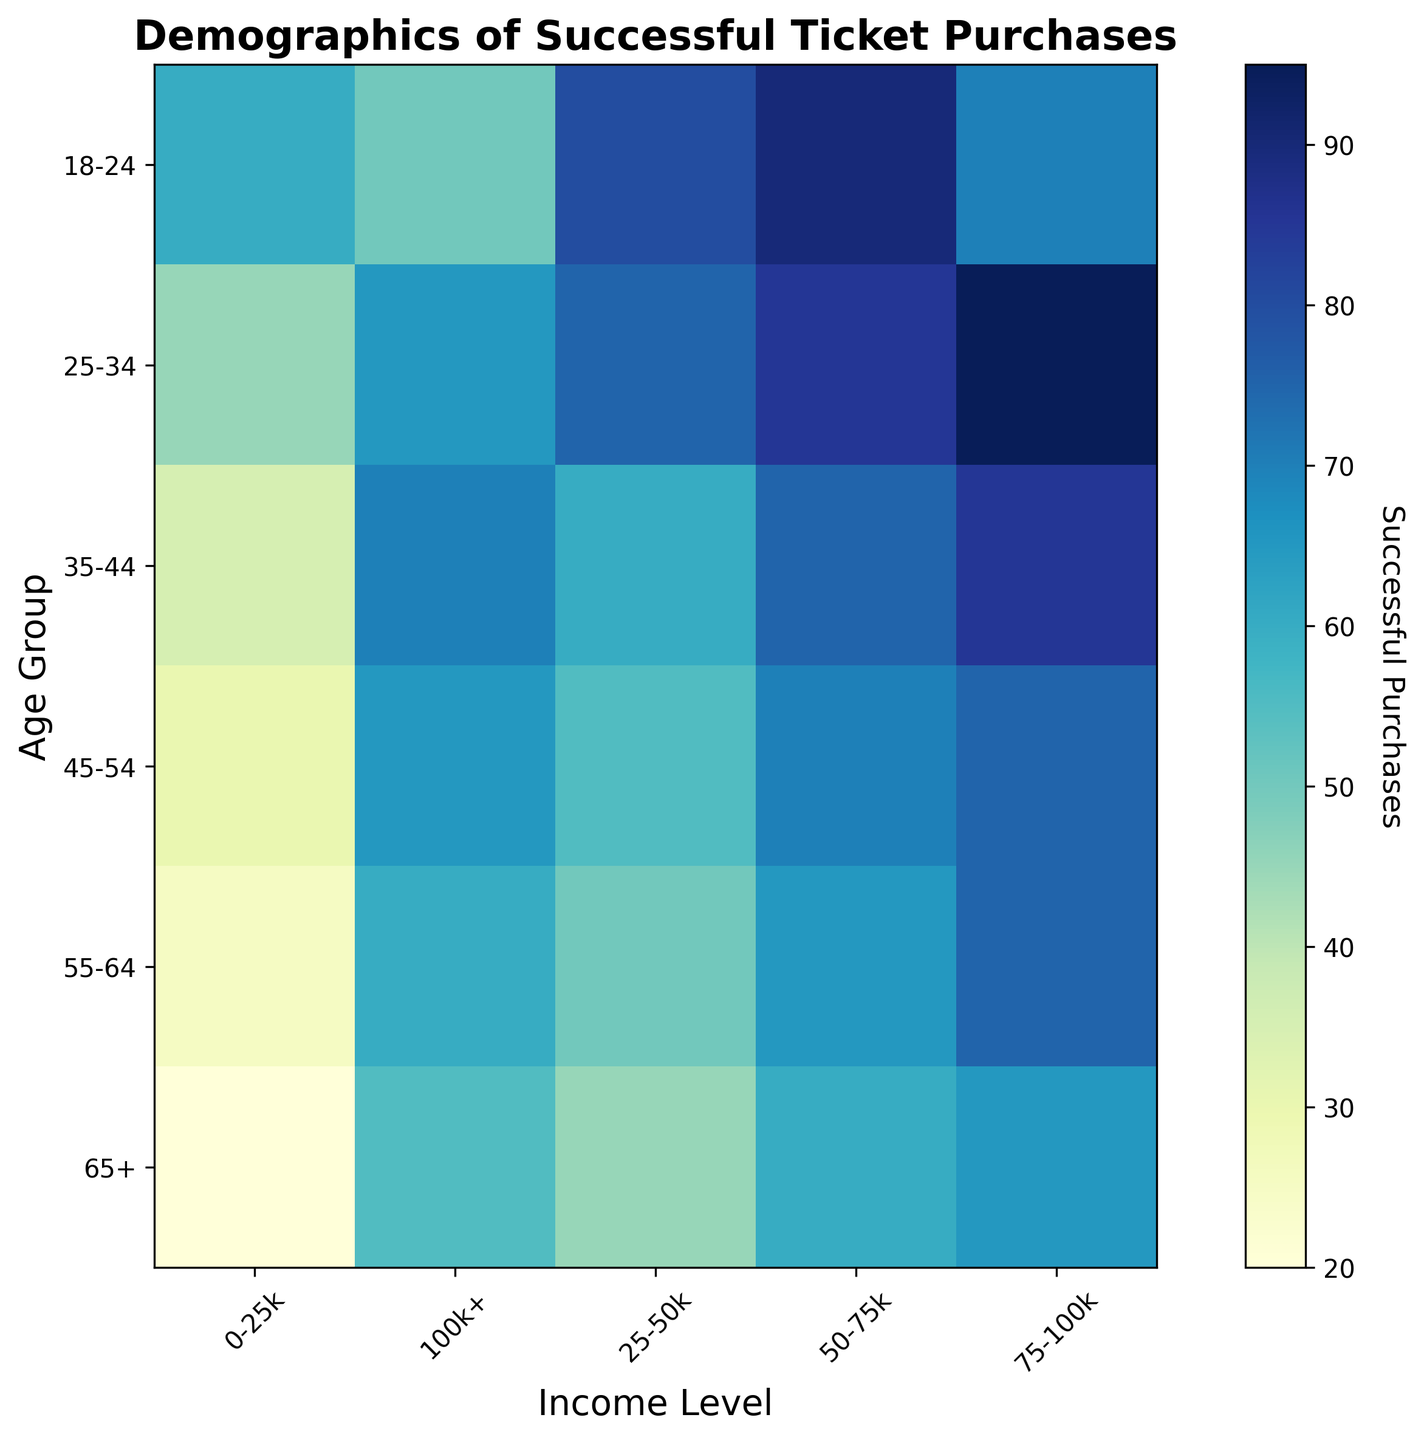What age group with an income of 75-100k has the highest successful purchases? Look at the age groups in the income level 75-100k and compare their successful purchases. The age groups are 18-24, 25-34, 35-44, 45-54, 55-64, and 65+. For 75-100k, the successful purchases are 70, 95, 85, 75, 75, and 65, respectively. The highest value is 95, which corresponds to the 25-34 age group.
Answer: 25-34 Which income level shows the least variation in successful purchases across all age groups? Evaluate the difference between the highest and lowest number of successful purchases within each income level across all age groups. The values for income levels can be computed as follows: 0-25k (60-20=40), 25-50k (80-45=35), 50-75k (90-60=30), 75-100k (85-65=20), and 100k+ (70-50=20). The least variation, 20, is shown by both the 75-100k and the 100k+ groups.
Answer: 75-100k and 100k+ Does an age group tend to have more successful purchases with an increase in income level? Observe the heatmap colors for each age group as the income level increases. For an age group, if the color becomes gradually darker, it indicates more successful purchases. For example, look at age group 18-24: 0-25k(60), 25-50k(80), 50-75k(90), 75-100k(70), and 100k+(50). Compare the patterns across all age groups. Multiple age groups including the 25-34 and 45-54 groups exhibit this trend, especially in income increments up to 75-100k.
Answer: Generally, yes Which age group with the lowest income level has the smallest number of successful purchases? Examine the age groups in the lowest income level (0-25k). Compare their successful purchases. The numbers are 60, 45, 35, 30, 25, and 20 for the age groups 18-24, 25-34, 35-44, 45-54, 55-64, and 65+ respectively. The smallest number is 20, which belongs to the 65+ age group.
Answer: 65+ Do younger age groups (18-24) generally have higher success rates in ticket purchases compared to older age groups (65+)? Compare the successful purchase numbers for the 18-24 age group and the 65+ age group across all income levels. The numbers for 18-24 are 60, 80, 90, 70, and 50. The numbers for 65+ are 20, 45, 60, 65, and 55. Since the values in the 18-24 range are overall higher compared to those in the 65+ range, younger groups generally do have higher success rates.
Answer: Yes What is the average number of successful purchases for the 35-44 age group across all income levels? Aggregate the successful purchases across all income levels for the 35-44 age group and divide by the number of income levels (5). The values are 35, 60, 75, 85, and 70. The sum is 35+60+75+85+70=325. The average is 325/5=65.
Answer: 65 